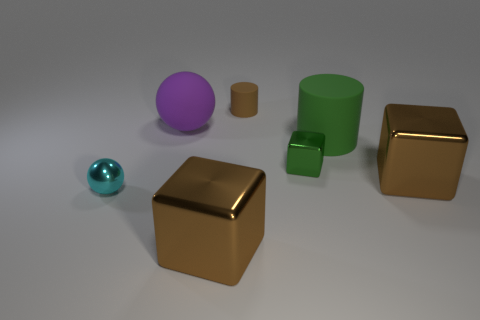Add 3 green metal cubes. How many objects exist? 10 Subtract all cylinders. How many objects are left? 5 Add 4 brown cylinders. How many brown cylinders are left? 5 Add 3 big green metal things. How many big green metal things exist? 3 Subtract 0 blue spheres. How many objects are left? 7 Subtract all large rubber objects. Subtract all small brown metallic balls. How many objects are left? 5 